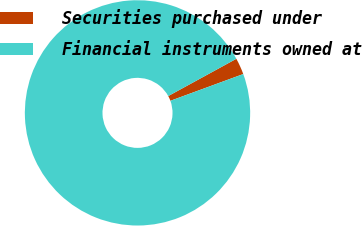Convert chart to OTSL. <chart><loc_0><loc_0><loc_500><loc_500><pie_chart><fcel>Securities purchased under<fcel>Financial instruments owned at<nl><fcel>2.37%<fcel>97.63%<nl></chart> 